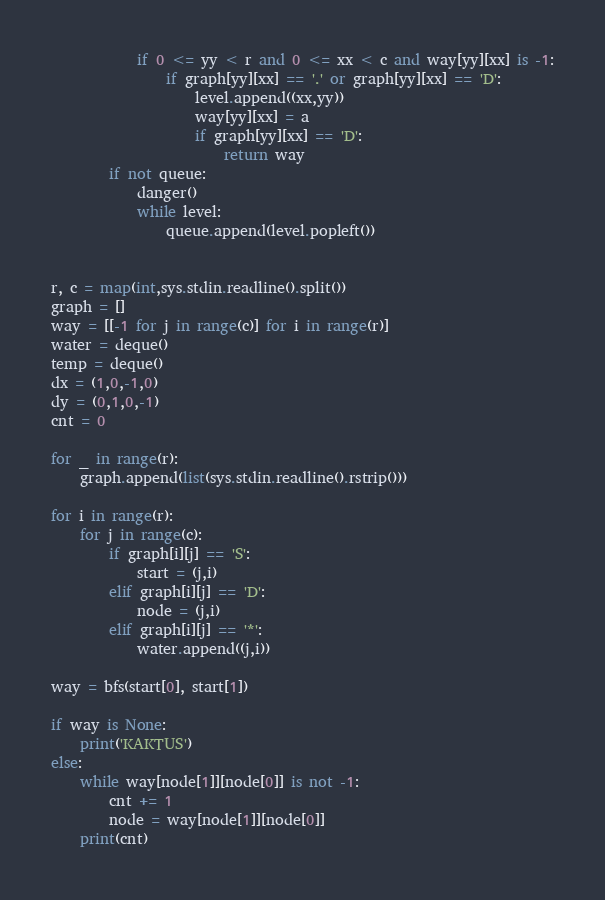<code> <loc_0><loc_0><loc_500><loc_500><_Python_>            if 0 <= yy < r and 0 <= xx < c and way[yy][xx] is -1:
                if graph[yy][xx] == '.' or graph[yy][xx] == 'D':
                    level.append((xx,yy))
                    way[yy][xx] = a
                    if graph[yy][xx] == 'D':
                        return way
        if not queue:
            danger()
            while level:
                queue.append(level.popleft())


r, c = map(int,sys.stdin.readline().split())
graph = []
way = [[-1 for j in range(c)] for i in range(r)]
water = deque()
temp = deque()
dx = (1,0,-1,0)
dy = (0,1,0,-1)
cnt = 0

for _ in range(r):
    graph.append(list(sys.stdin.readline().rstrip()))

for i in range(r):
    for j in range(c):
        if graph[i][j] == 'S':
            start = (j,i)
        elif graph[i][j] == 'D':
            node = (j,i)
        elif graph[i][j] == '*':
            water.append((j,i))

way = bfs(start[0], start[1])

if way is None:
    print('KAKTUS')
else:
    while way[node[1]][node[0]] is not -1:
        cnt += 1
        node = way[node[1]][node[0]]
    print(cnt)</code> 